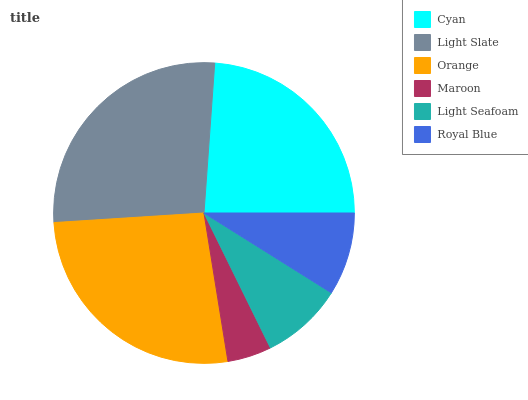Is Maroon the minimum?
Answer yes or no. Yes. Is Light Slate the maximum?
Answer yes or no. Yes. Is Orange the minimum?
Answer yes or no. No. Is Orange the maximum?
Answer yes or no. No. Is Light Slate greater than Orange?
Answer yes or no. Yes. Is Orange less than Light Slate?
Answer yes or no. Yes. Is Orange greater than Light Slate?
Answer yes or no. No. Is Light Slate less than Orange?
Answer yes or no. No. Is Cyan the high median?
Answer yes or no. Yes. Is Royal Blue the low median?
Answer yes or no. Yes. Is Light Slate the high median?
Answer yes or no. No. Is Light Seafoam the low median?
Answer yes or no. No. 